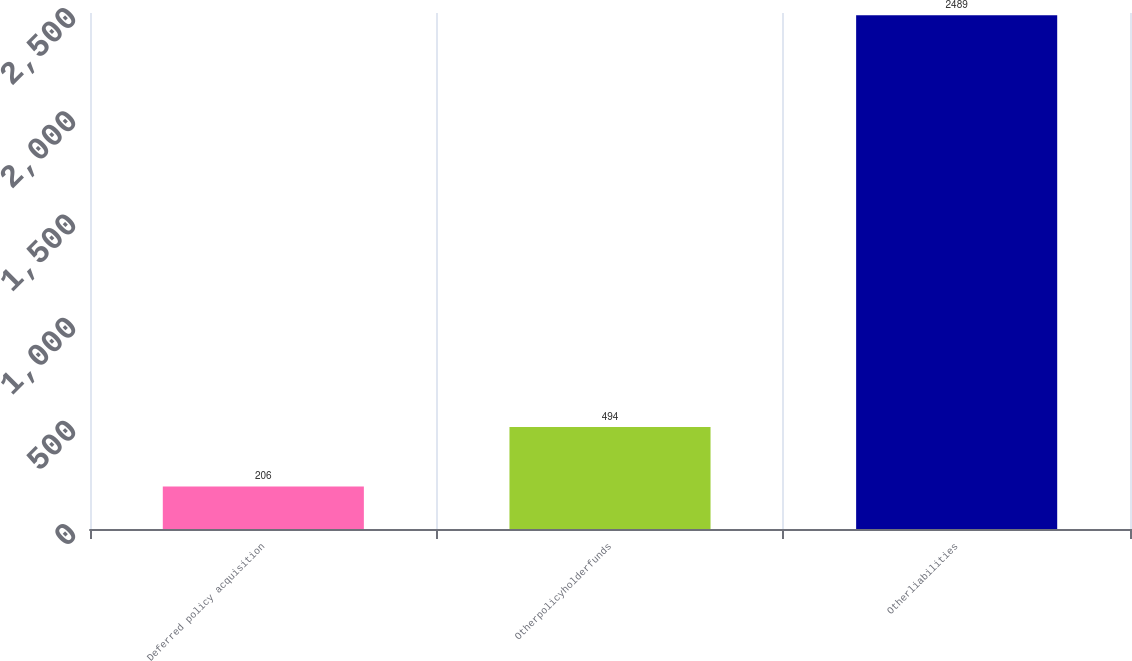Convert chart to OTSL. <chart><loc_0><loc_0><loc_500><loc_500><bar_chart><fcel>Deferred policy acquisition<fcel>Otherpolicyholderfunds<fcel>Otherliabilities<nl><fcel>206<fcel>494<fcel>2489<nl></chart> 